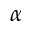<formula> <loc_0><loc_0><loc_500><loc_500>\alpha</formula> 